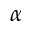<formula> <loc_0><loc_0><loc_500><loc_500>\alpha</formula> 